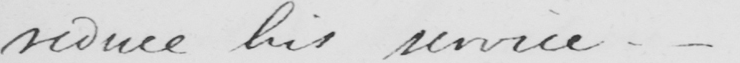Please transcribe the handwritten text in this image. reduce his service . 